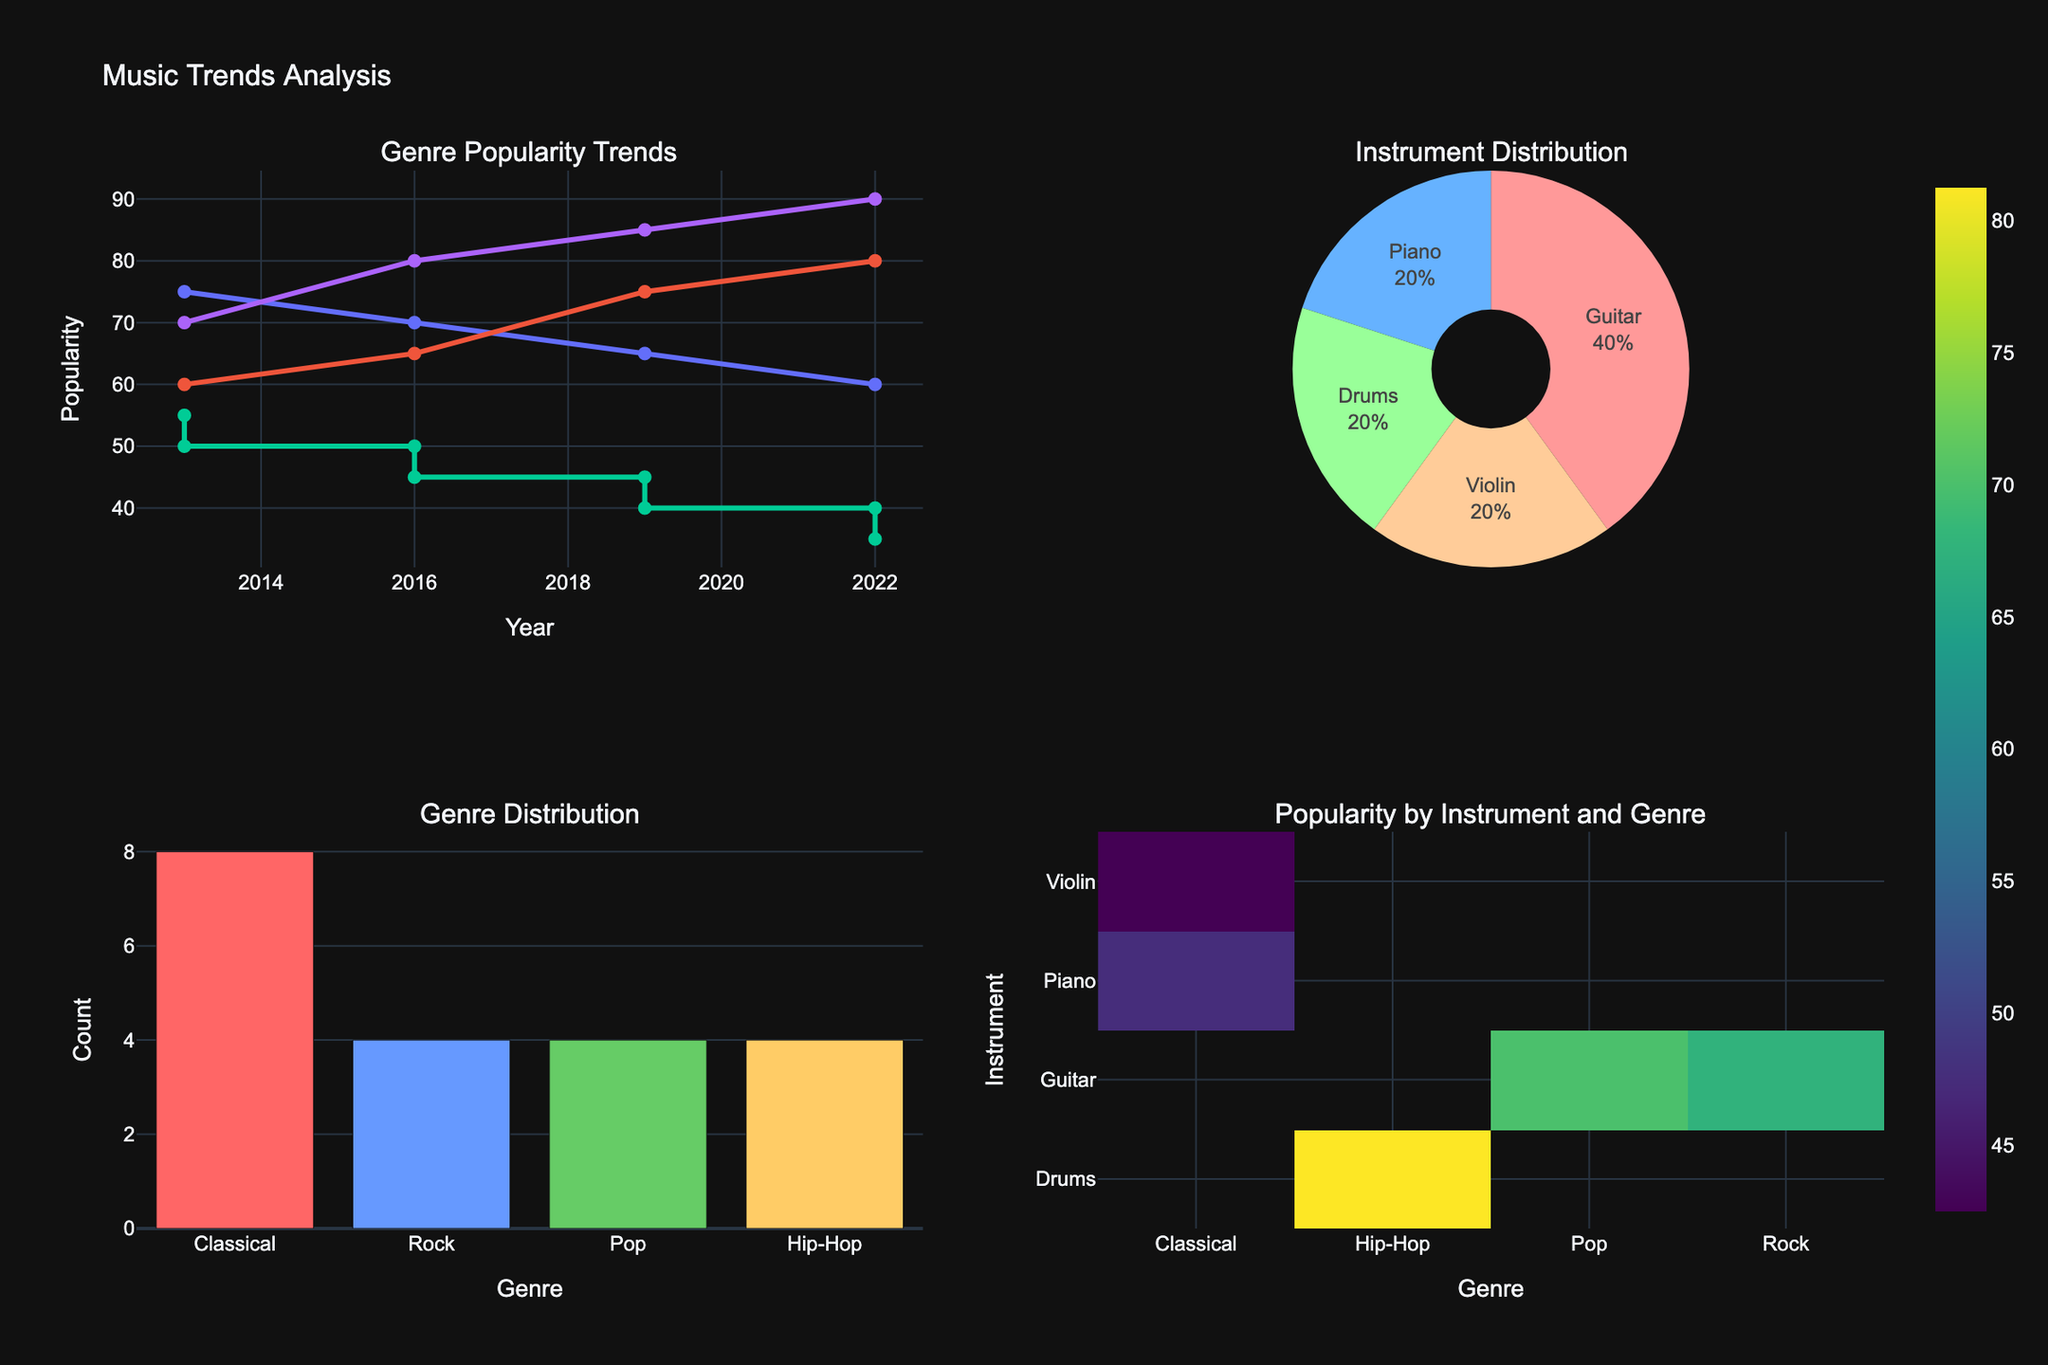what is the most popular genre for guitar players in 2022? Refer to the Line plot for Genre Popularity Trends, find the line corresponding to "Guitar" and look for the highest data point in 2022. The genres are labeled.
Answer: Pop which instrument has shown the greatest increase in popularity in Hip-Hop from 2013 to 2022? Find the data points for Hip-Hop in 2013 and 2022 on the Line plot for Genre Popularity Trends. Compare the values for each instrument. The greatest increase in popularity from 2013 to 2022 is what we’re looking for.
Answer: Drums What genre associated with the piano has the least popularity in 2022? Check the Line plot for Genre Popularity Trends, and locate the data point for Piano in 2022. Identify the corresponding genre and note its popularity score.
Answer: Classical which instrument and genre combination is most popular overall in 2022? Refer to the Heatmap for Popularity by Instrument and Genre in the bottom right of the figure, find the cell with the highest value for the year 2022.
Answer: Drums, Hip-Hop How has the popularity of Rock among guitar players changed from 2013 to 2022? Examine the Line plot for Genre Popularity Trends. Locate the trend line for Guitar and the labels for Rock from 2013 to 2022. Calculate the difference between the 2022 value and the 2013 value.
Answer: Decreased by 15 points Which genre appears to have the most consistent popularity between 2013 and 2022 according to the line plot? Review the Line plot for Genre Popularity Trends and identify which genre shows the least fluctuation in popularity values from 2013 to 2022.
Answer: Classical 